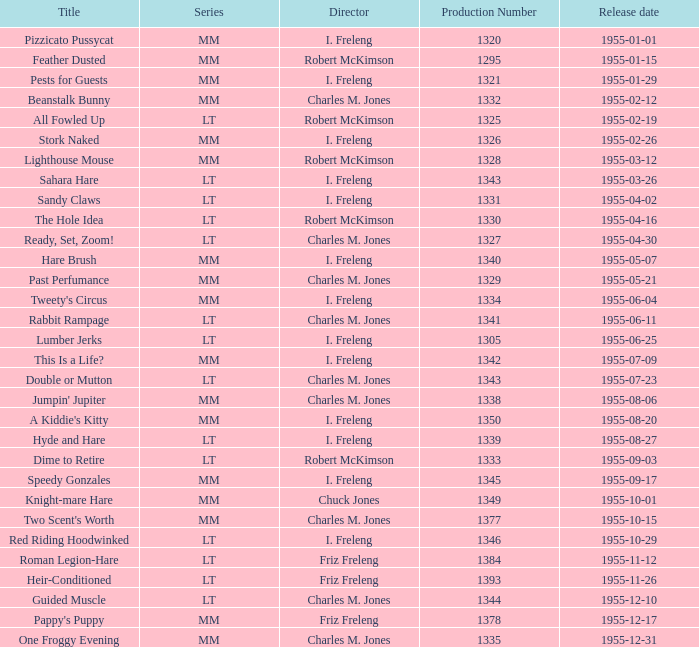What is the unveiling date of production number 1327? 1955-04-30. 